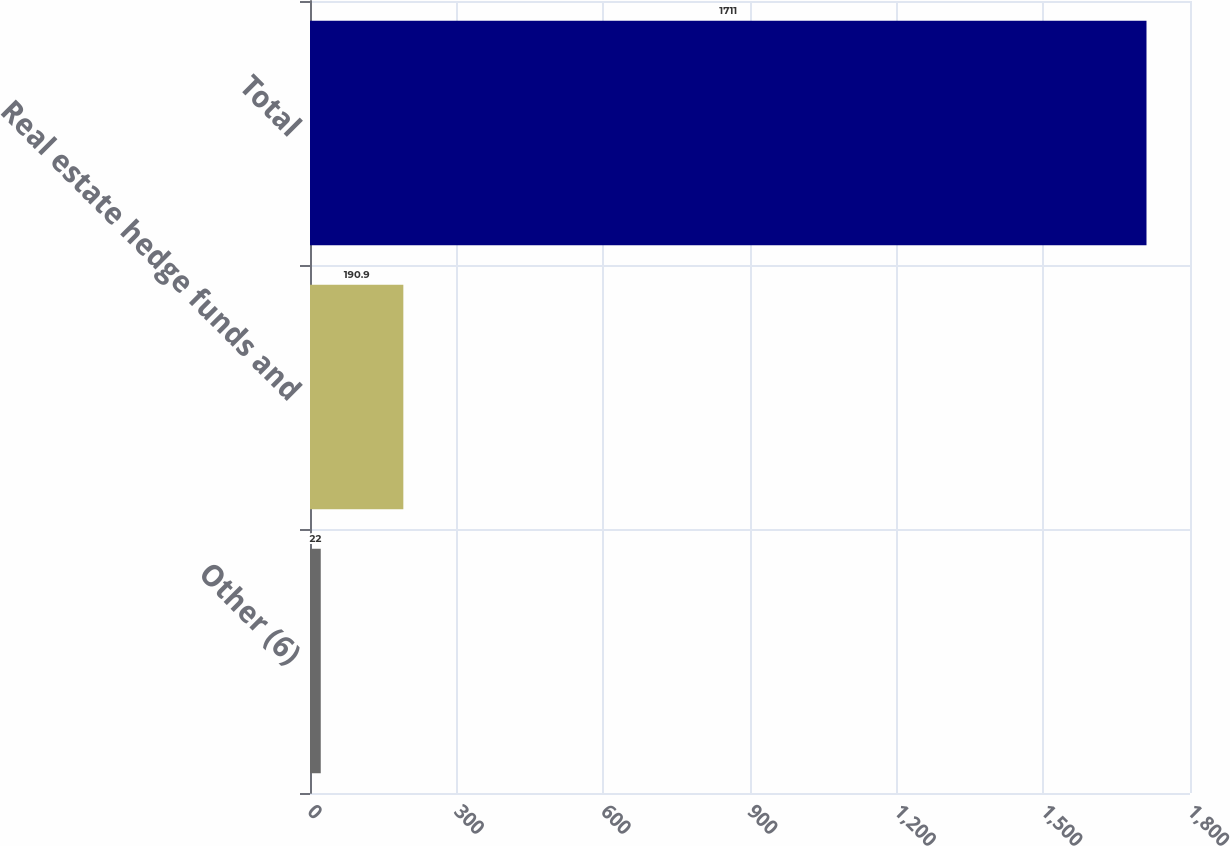<chart> <loc_0><loc_0><loc_500><loc_500><bar_chart><fcel>Other (6)<fcel>Real estate hedge funds and<fcel>Total<nl><fcel>22<fcel>190.9<fcel>1711<nl></chart> 